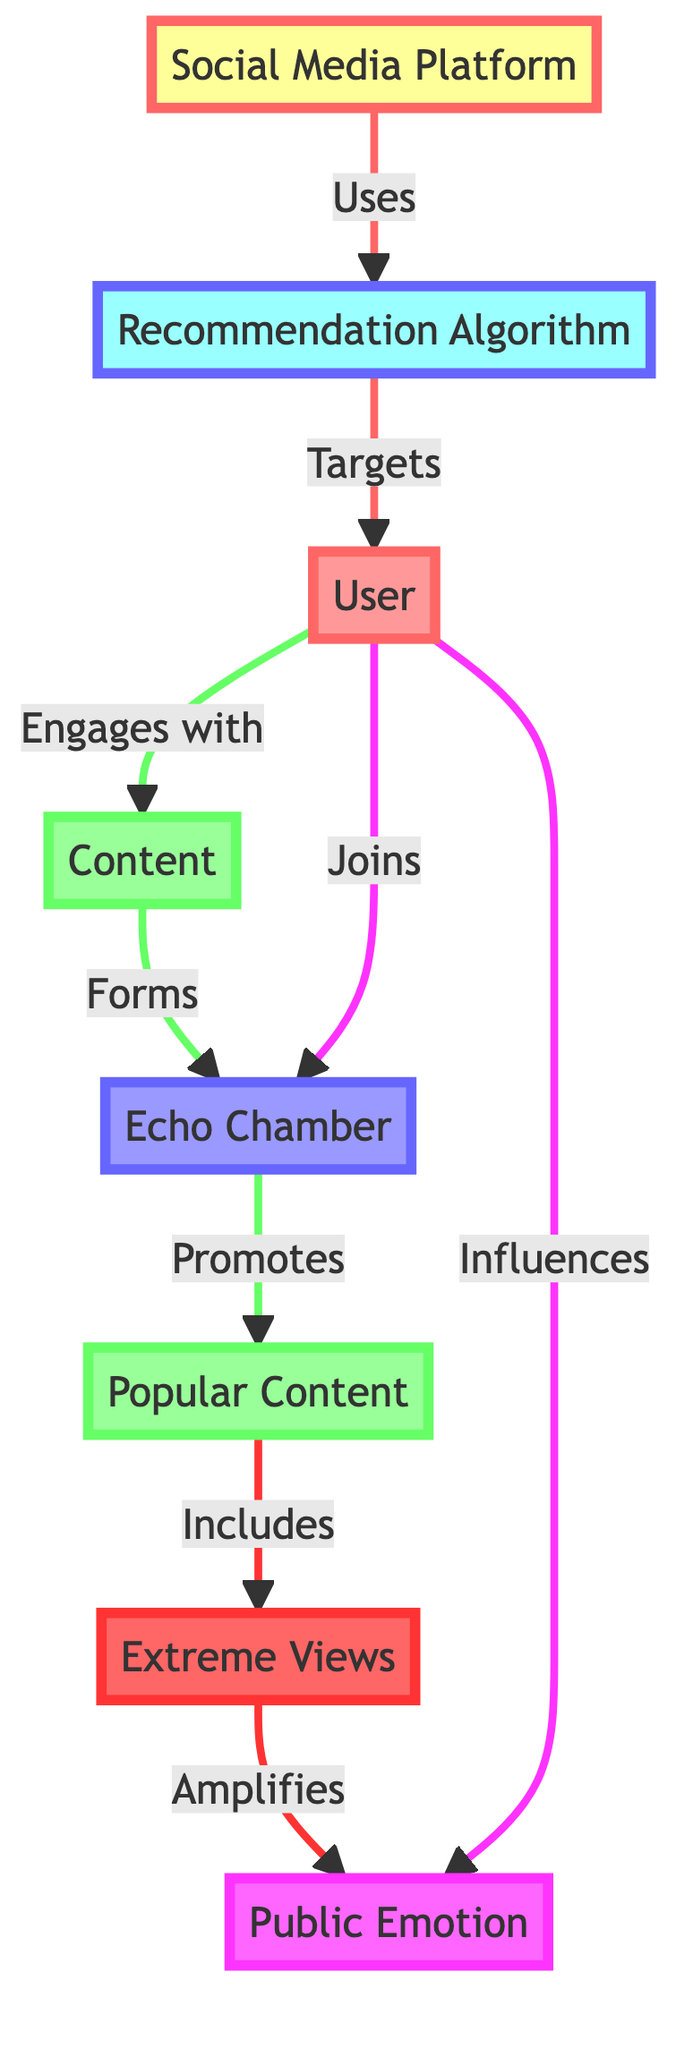What is the role of the Recommendation Algorithm? The Recommendation Algorithm is used by the Social Media Platform. It serves to target Users based on their interactions and preferences, guiding them to content that they are likely to engage with.
Answer: Uses How many nodes are in the diagram? The diagram has eight distinct nodes: Social Media Platform, Recommendation Algorithm, User, Content, Echo Chamber, Popular Content, Extreme Views, and Public Emotion. Therefore, the total number of nodes is eight.
Answer: Eight What does the Echo Chamber promote? The Echo Chamber promotes Popular Content as part of its function. This indicates that the content within echo chambers is typically favored and circulated among users who join these closed networks.
Answer: Promotes What is the flow from Extreme Views to Public Emotion? The flow from Extreme Views to Public Emotion is a direct link that illustrates how extreme views amplify public emotion. It shows that as extreme content is consumed, it intensifies the emotional response of users.
Answer: Amplifies How do Users influence Public Emotion? Users influence Public Emotion by engaging with and promoting certain types of content, particularly within an Echo Chamber. This indicates a feedback loop where user interactions with extreme views and content shape collective emotions in the society.
Answer: Influences What type of content includes Extreme Views? Popular Content includes Extreme Views. This connection highlights that content that gets a lot of engagement often consists of more extreme perspectives, bolstering their presence within the echo chambers.
Answer: Includes What connects Users to Echo Chambers? Users join Echo Chambers as part of their engagement with the content curated by the platform's algorithms. This joining process is an integral aspect of how echo chambers form and thrive on social media platforms.
Answer: Joins 